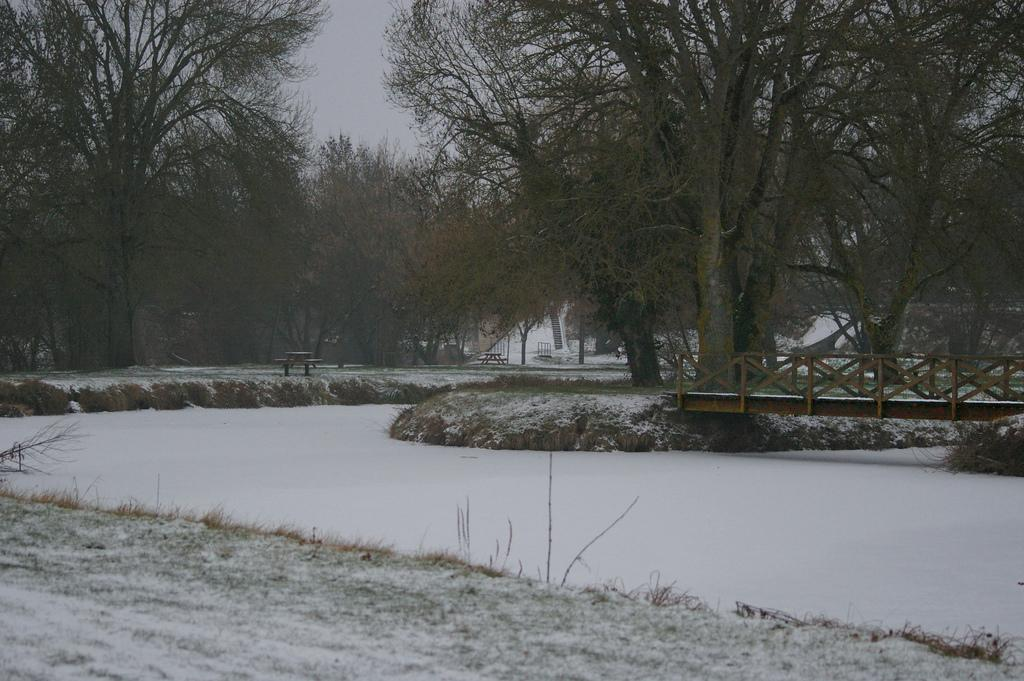What type of terrain is visible in the foreground of the image? There is land and snow in the foreground of the image. What structures can be seen in the foreground of the image? There is a bridge and benches visible in the foreground of the image. What type of vegetation is present in the foreground of the image? There are trees in the foreground of the image. What part of the natural environment is visible in the image? The sky is visible in the image. What type of leather is used to make the finger locket in the image? There is no leather or finger locket present in the image. 